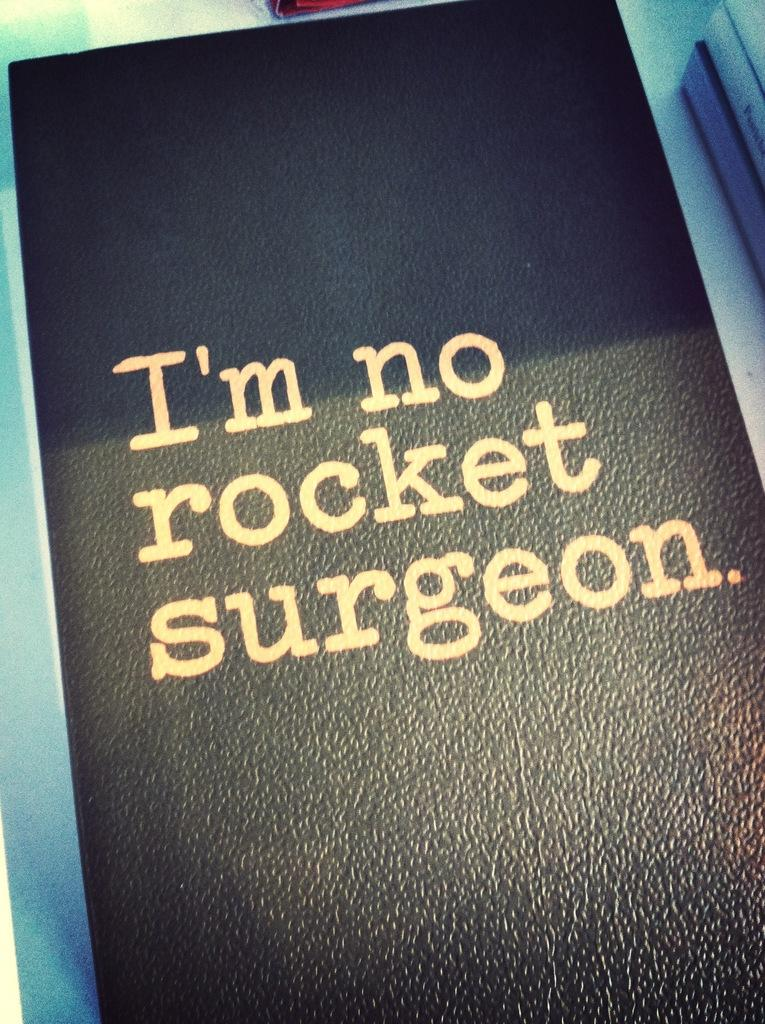<image>
Give a short and clear explanation of the subsequent image. Looks like a diary with a title on it as I'm no rocket surgeon. 